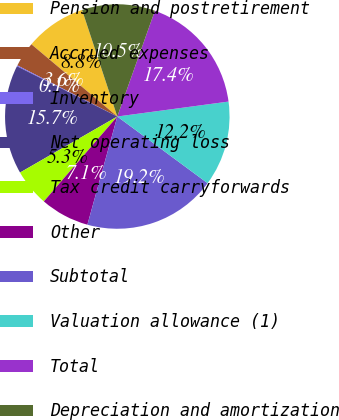Convert chart. <chart><loc_0><loc_0><loc_500><loc_500><pie_chart><fcel>Pension and postretirement<fcel>Accrued expenses<fcel>Inventory<fcel>Net operating loss<fcel>Tax credit carryforwards<fcel>Other<fcel>Subtotal<fcel>Valuation allowance (1)<fcel>Total<fcel>Depreciation and amortization<nl><fcel>8.79%<fcel>3.6%<fcel>0.14%<fcel>15.71%<fcel>5.33%<fcel>7.06%<fcel>19.17%<fcel>12.25%<fcel>17.44%<fcel>10.52%<nl></chart> 